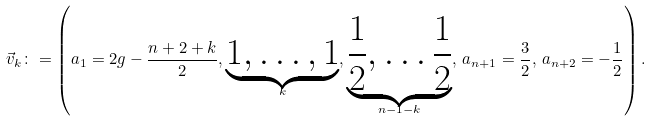<formula> <loc_0><loc_0><loc_500><loc_500>\vec { v } _ { k } \colon = \left ( a _ { 1 } = 2 g - \frac { n + 2 + k } { 2 } , \underbrace { 1 , \dots , 1 } _ { k } , \underbrace { \frac { 1 } { 2 } , \dots \frac { 1 } { 2 } } _ { n - 1 - k } , \, a _ { n + 1 } = \frac { 3 } { 2 } , \, a _ { n + 2 } = - \frac { 1 } { 2 } \right ) .</formula> 